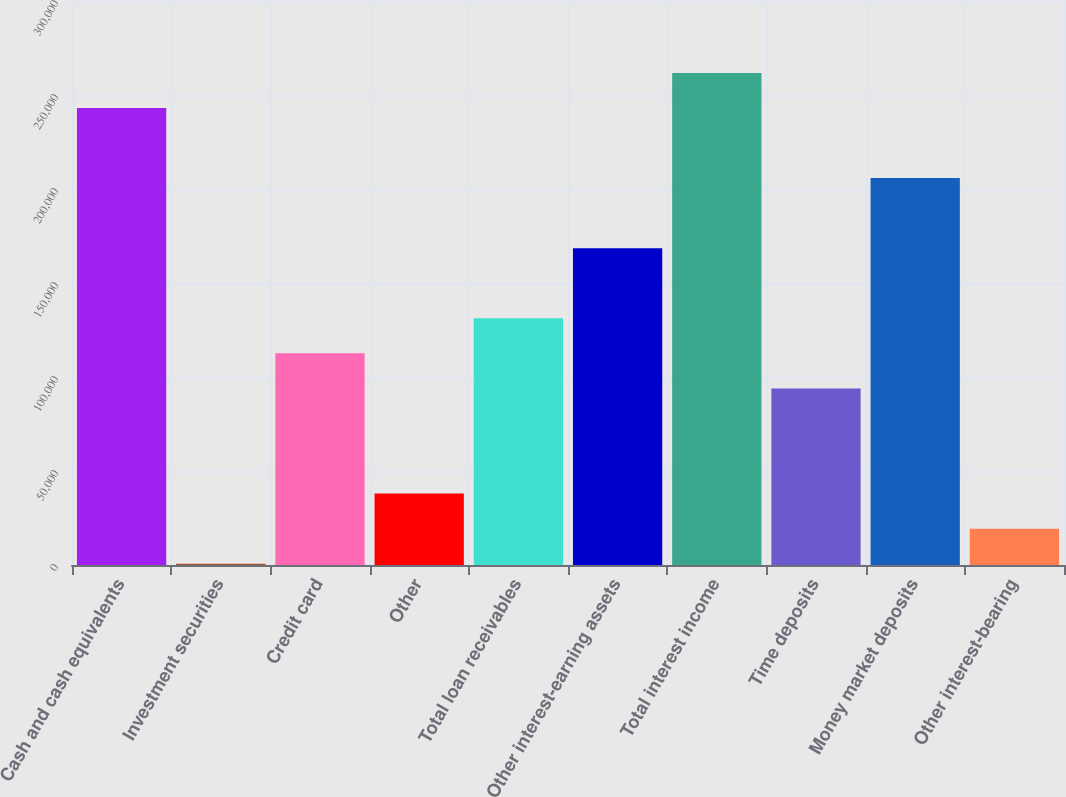<chart> <loc_0><loc_0><loc_500><loc_500><bar_chart><fcel>Cash and cash equivalents<fcel>Investment securities<fcel>Credit card<fcel>Other<fcel>Total loan receivables<fcel>Other interest-earning assets<fcel>Total interest income<fcel>Time deposits<fcel>Money market deposits<fcel>Other interest-bearing<nl><fcel>243099<fcel>693<fcel>112573<fcel>37986.2<fcel>131219<fcel>168512<fcel>261745<fcel>93926<fcel>205806<fcel>19339.6<nl></chart> 